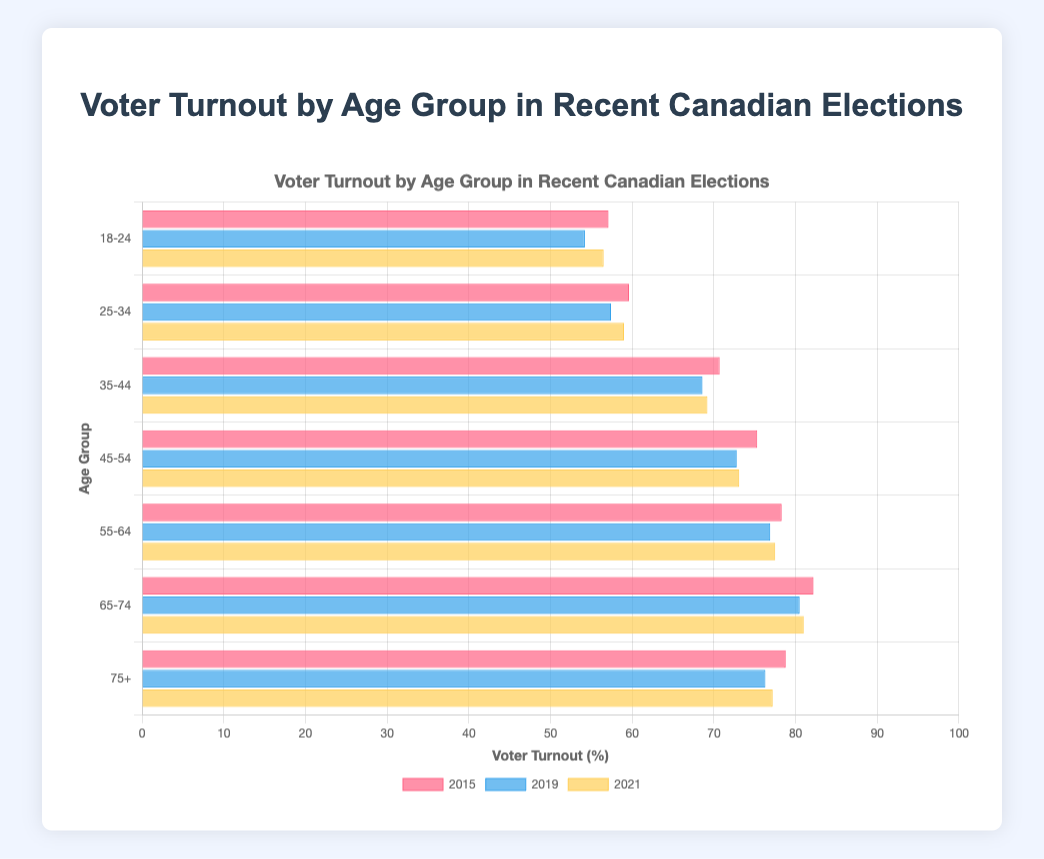What is the voter turnout for the age group 18-24 in the 2021 election? The horizontal grouped bar chart shows voter turnout by age group for the years 2015, 2019, and 2021. The bar for the age group 18-24 in 2021 is marked, showing 56.5%.
Answer: 56.5% Which age group had the highest voter turnout in 2015? By examining the bars for each age group in the year 2015, the highest bar corresponds to the age group 65-74 with a voter turnout of 82.2%.
Answer: 65-74 How did voter turnout change for the age group 25-34 from 2015 to 2019? The voter turnout for the age group 25-34 in 2015 was 59.6%, while in 2019 it was 57.4%. The change in voter turnout is 59.6 - 57.4 = 2.2%.
Answer: Decreased by 2.2% Which age group saw the most significant increase in voter turnout from 2019 to 2021? Comparing the bar lengths for each age group between 2019 and 2021, the age group 18-24 had an increase from 54.2% to 56.5%, which is an increase of 2.3%. This is the largest increase among all age groups.
Answer: 18-24 What is the average voter turnout for all age groups in the 2019 election? To find the average: (54.2 + 57.4 + 68.6 + 72.8 + 76.9 + 80.5 + 76.3) / 7 = 69.52%.
Answer: 69.5% Identify the trend in voter turnout for the age group 65-74 over the three election years. The voter turnout for the age group 65-74 was 82.2% in 2015, 80.5% in 2019, and 81.0% in 2021. This denotes a slight decrease in 2019 compared to 2015 but an increase again in 2021.
Answer: Minor fluctuation with overall high turnout Compare the voter turnout for the age group 75+ in 2015 and 2021. The voter turnout for the age group 75+ was 78.8% in 2015 and 77.2% in 2021. There is a decrease of 78.8 - 77.2 = 1.6%.
Answer: Decreased by 1.6% Which election year had the overall highest voter turnout on average across all age groups? Calculate the average turnout for each year: 
2015: (57.1 + 59.6 + 70.7 + 75.3 + 78.3 + 82.2 + 78.8) / 7 = 71.43,
2019: (54.2 + 57.4 + 68.6 + 72.8 + 76.9 + 80.5 + 76.3) / 7 = 69.52,
2021: (56.5 + 59.0 + 69.2 + 73.1 + 77.5 + 81.0 + 77.2) / 7 = 70.50.
Thus, 2015 had the highest average voter turnout.
Answer: 2015 